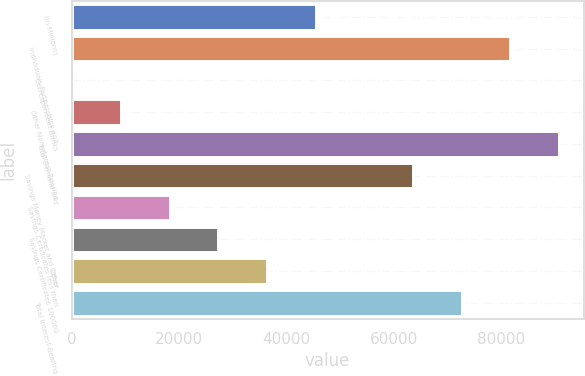Convert chart to OTSL. <chart><loc_0><loc_0><loc_500><loc_500><bar_chart><fcel>(In Millions)<fcel>Individuals Partnerships and<fcel>Correspondent Banks<fcel>Other Noninterest-Bearing<fcel>Total Demand and<fcel>Savings Money Market and Other<fcel>Savings Certificates less than<fcel>Savings Certificates 100000<fcel>Other<fcel>Total Interest-Bearing<nl><fcel>45413.9<fcel>81697.2<fcel>59.8<fcel>9130.62<fcel>90768<fcel>63555.5<fcel>18201.4<fcel>27272.3<fcel>36343.1<fcel>72626.4<nl></chart> 